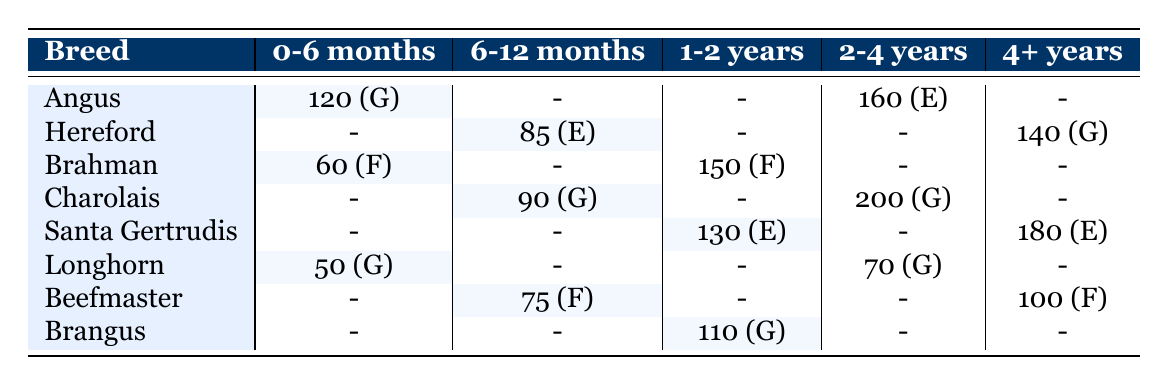What is the total number of Angus livestock by age group? To find the total number of Angus livestock, I look at the row for Angus. The data shows there are 120 Angus in the 0-6 months age group and 160 in the 2-4 years age group. Adding these values gives: 120 + 160 = 280.
Answer: 280 Which breed has the highest count of livestock in the 2-4 years age group? To determine this, I examine the values in the 2-4 years column. The Charolais breed has the highest count with 200 livestock, while Santa Gertrudis has 0. Therefore, the breed with the highest count is Charolais.
Answer: Charolais Is there any breed that has livestock in the 6-12 months age group with a health status of "Excellent"? I look in the 6-12 months column for health status marked as "Excellent." The only breed listed here is Hereford, which has 85 livestock and a health status of "Excellent." So, the answer is yes.
Answer: Yes What is the average count of livestock across all breeds in the 4+ years age group? To find the average count for the 4+ years age group, I first identify the counts for each breed in this age group: Santa Gertrudis (180) and Beefmaster (100). Adding these gives: 180 + 100 = 280. There are 2 entries, so the average is 280 / 2 = 140.
Answer: 140 How many breeds have a health status of "Good" in the 0-6 months age group? I reference the 0-6 months column and count the breeds with a health status of "Good." Angus (120) and Longhorn (50) are the only two. Therefore, the count is 2.
Answer: 2 Which age group has the most livestock with a health status of "Fair"? I check each age group's associated health status. For 0-6 months, Brahman has 60 (Fair); for 6-12 months, Beefmaster has 75 (Fair); for 1-2 years, Brahman has 150 (Fair); for 2-4 years, there are 0 entries; for 4+ years, Beefmaster has 100 (Fair). The highest count is in the 1-2 years age group with 150 livestock.
Answer: 1-2 years Are there more Santa Gertrudis than Brahman livestock in the 1-2 years age group? I compare the counts for Santa Gertrudis (130) and Brahman (150) in the 1-2 years age group. Brahman has a higher count, so the answer is no.
Answer: No What percentage of Longhorn livestock has a "Good" health status in the 2-4 years age group? Longhorn has 70 livestock in the 2-4 years category, but this group is marked as "Good." To find the percentage based on available Longhorn data: Longhorn has 50 in 0-6 months (Good) and 70 in 2-4 years (Good), so total Longhorn = 50 + 70 = 120. Thus, 70/120 * 100 = 58.33%.
Answer: 58.33% In which categories are the "Partial" vaccination status livestock located? Checking the vaccination status, I find "Partial" in the 1-2 years age for Brahman (150) and 4+ years for Hereford (140). Hence, both age groups with "Partial" status are 1-2 years and 4+ years.
Answer: 1-2 years and 4+ years 